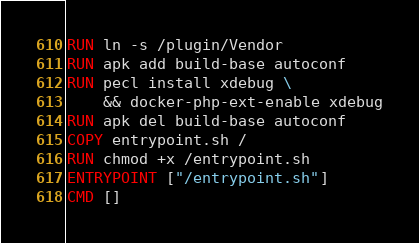<code> <loc_0><loc_0><loc_500><loc_500><_Dockerfile_>RUN ln -s /plugin/Vendor
RUN apk add build-base autoconf
RUN pecl install xdebug \
    && docker-php-ext-enable xdebug
RUN apk del build-base autoconf
COPY entrypoint.sh /
RUN chmod +x /entrypoint.sh
ENTRYPOINT ["/entrypoint.sh"]
CMD []
</code> 